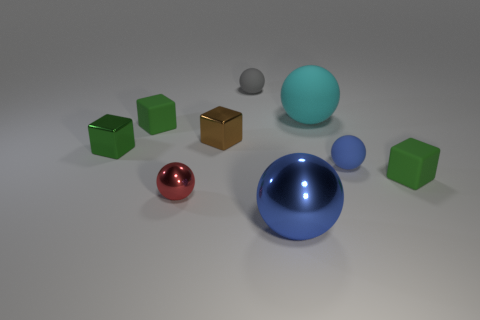How many other blue things are the same shape as the large metallic thing?
Provide a succinct answer. 1. What material is the tiny thing that is both in front of the tiny blue object and on the right side of the cyan rubber object?
Your answer should be compact. Rubber. How many small rubber balls are behind the tiny brown object?
Ensure brevity in your answer.  1. How many large cyan matte objects are there?
Provide a succinct answer. 1. Is the brown metallic cube the same size as the green metal object?
Make the answer very short. Yes. Is there a blue matte object to the right of the tiny green rubber block that is right of the small rubber object that is on the left side of the small red object?
Give a very brief answer. No. What is the material of the cyan thing that is the same shape as the red metallic thing?
Ensure brevity in your answer.  Rubber. What color is the big ball that is behind the small blue rubber thing?
Provide a succinct answer. Cyan. The cyan rubber object is what size?
Provide a short and direct response. Large. There is a green metallic cube; is it the same size as the blue ball that is behind the blue metallic object?
Provide a succinct answer. Yes. 